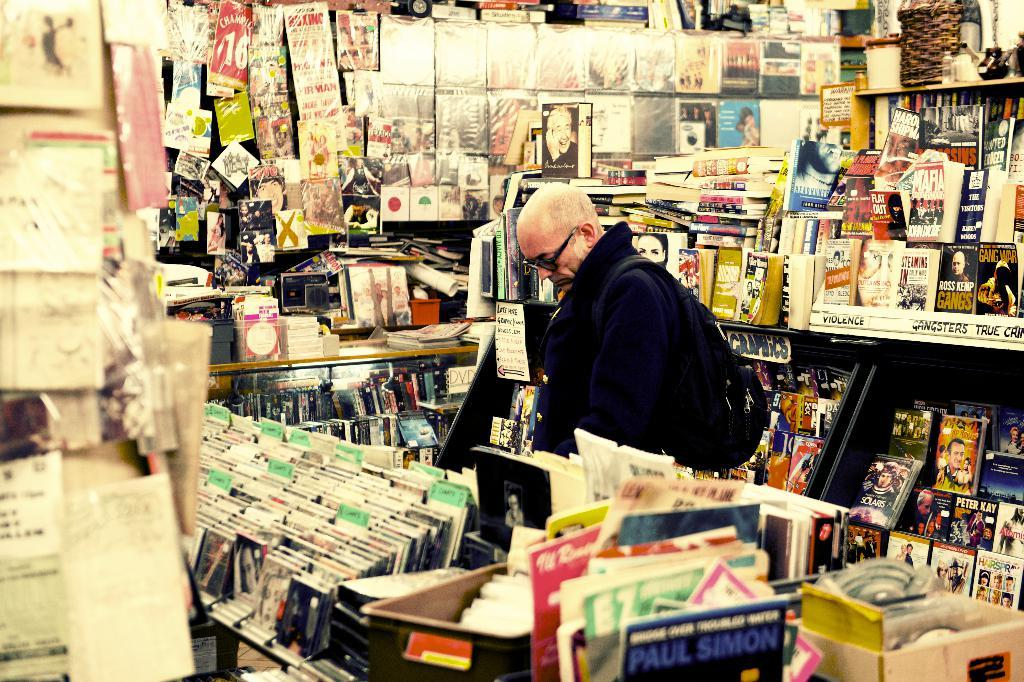<image>
Provide a brief description of the given image. A man browses the selection of books and movies ranging from Paul Simon to Solaris. 